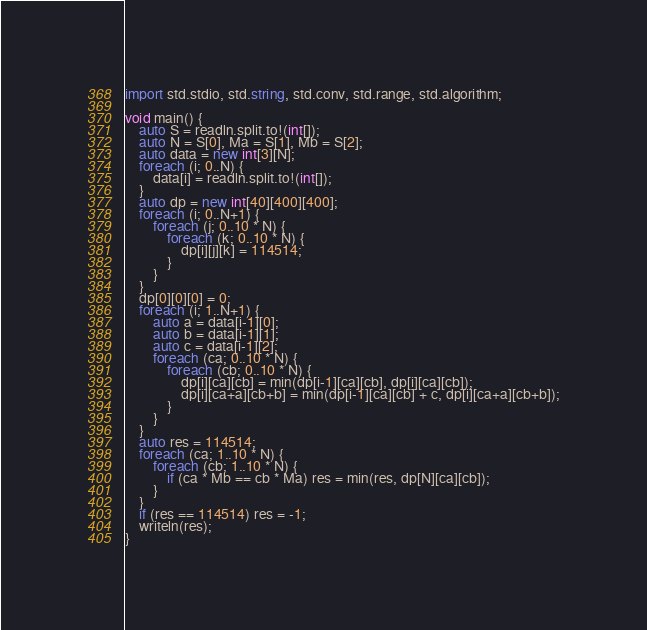Convert code to text. <code><loc_0><loc_0><loc_500><loc_500><_D_>import std.stdio, std.string, std.conv, std.range, std.algorithm;

void main() {
    auto S = readln.split.to!(int[]);
    auto N = S[0], Ma = S[1], Mb = S[2];
    auto data = new int[3][N];
    foreach (i; 0..N) {
        data[i] = readln.split.to!(int[]);
    }
    auto dp = new int[40][400][400];
    foreach (i; 0..N+1) {
        foreach (j; 0..10 * N) {
            foreach (k; 0..10 * N) {
                dp[i][j][k] = 114514;
            }
        }
    }
    dp[0][0][0] = 0;
    foreach (i; 1..N+1) {
        auto a = data[i-1][0];
        auto b = data[i-1][1];
        auto c = data[i-1][2];
        foreach (ca; 0..10 * N) {
            foreach (cb; 0..10 * N) {
                dp[i][ca][cb] = min(dp[i-1][ca][cb], dp[i][ca][cb]);
                dp[i][ca+a][cb+b] = min(dp[i-1][ca][cb] + c, dp[i][ca+a][cb+b]);
            }
        }
    }
    auto res = 114514;
    foreach (ca; 1..10 * N) {
        foreach (cb; 1..10 * N) {
            if (ca * Mb == cb * Ma) res = min(res, dp[N][ca][cb]);
        }
    }
    if (res == 114514) res = -1;
    writeln(res);
}</code> 